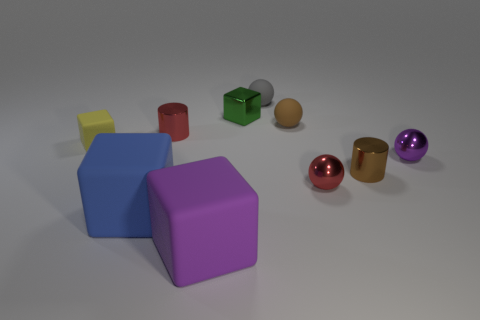What materials do these objects appear to be made of? The objects in the image seem to have a smooth, matte finish that's reminiscent of plastic or rubber. There is no shininess that would suggest a metallic material and they don't appear to have the texture of fabric or paper products. 